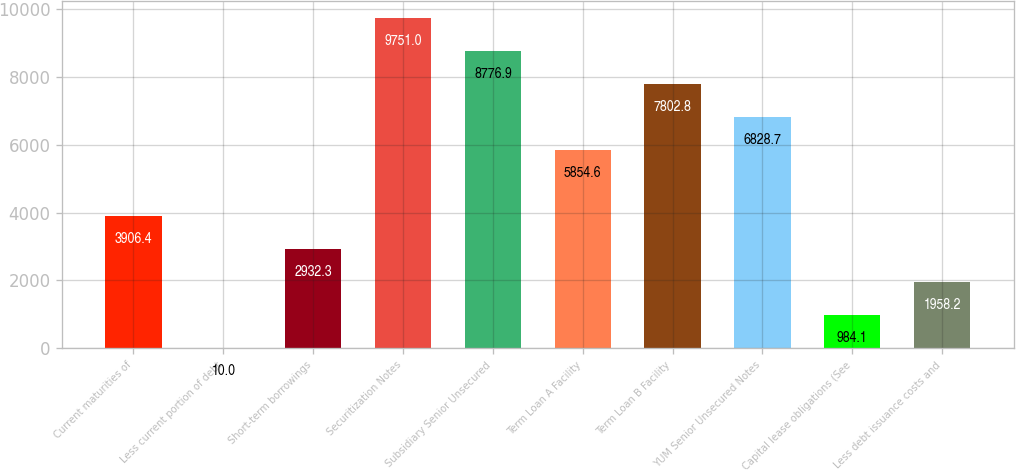Convert chart. <chart><loc_0><loc_0><loc_500><loc_500><bar_chart><fcel>Current maturities of<fcel>Less current portion of debt<fcel>Short-term borrowings<fcel>Securitization Notes<fcel>Subsidiary Senior Unsecured<fcel>Term Loan A Facility<fcel>Term Loan B Facility<fcel>YUM Senior Unsecured Notes<fcel>Capital lease obligations (See<fcel>Less debt issuance costs and<nl><fcel>3906.4<fcel>10<fcel>2932.3<fcel>9751<fcel>8776.9<fcel>5854.6<fcel>7802.8<fcel>6828.7<fcel>984.1<fcel>1958.2<nl></chart> 